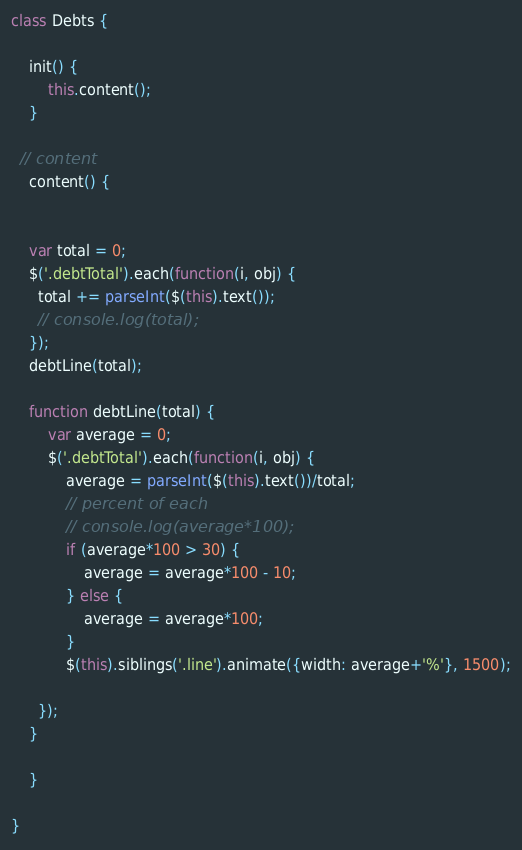<code> <loc_0><loc_0><loc_500><loc_500><_JavaScript_>class Debts {

	init() {
		this.content();
	}

  // content
	content() {


    var total = 0;
    $('.debtTotal').each(function(i, obj) {
      total += parseInt($(this).text());
      // console.log(total);
    });
    debtLine(total);

  	function debtLine(total) {
  		var average = 0;
  		$('.debtTotal').each(function(i, obj) {
  			average = parseInt($(this).text())/total;
  			// percent of each
    		// console.log(average*100);
  			if (average*100 > 30) {
  				average = average*100 - 10;
  			} else {
  				average = average*100;
  			}
  			$(this).siblings('.line').animate({width: average+'%'}, 1500);

      });
  	}

	}

}
</code> 